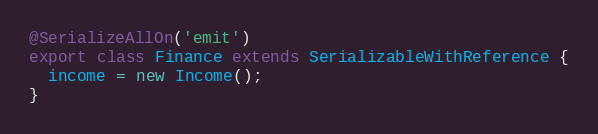<code> <loc_0><loc_0><loc_500><loc_500><_TypeScript_>@SerializeAllOn('emit')
export class Finance extends SerializableWithReference {
  income = new Income();
}
</code> 